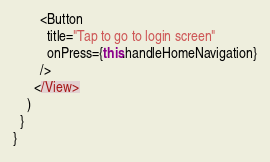Convert code to text. <code><loc_0><loc_0><loc_500><loc_500><_JavaScript_>        <Button
          title="Tap to go to login screen"
          onPress={this.handleHomeNavigation}
        />
      </View>
    )
  }
}
</code> 